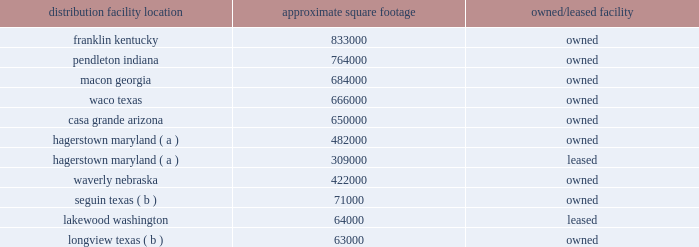The following is a list of distribution locations including the approximate square footage and if the location is leased or owned: .
Longview , texas ( b ) 63000 owned ( a ) the leased facility in hagerstown is treated as an extension of the existing owned hagerstown location and is not considered a separate distribution center .
( b ) this is a mixing center designed to process certain high-volume bulk products .
The company 2019s store support center occupies approximately 260000 square feet of owned building space in brentwood , tennessee , and the company 2019s merchandising innovation center occupies approximately 32000 square feet of leased building space in nashville , tennessee .
The company also leases approximately 8000 square feet of building space for the petsense corporate headquarters located in scottsdale , arizona .
In fiscal 2017 , we began construction on a new northeast distribution center in frankfort , new york , as well as an expansion of our existing distribution center in waverly , nebraska , which will provide additional distribution capacity once construction is completed .
Item 3 .
Legal proceedings item 103 of sec regulation s-k requires disclosure of certain environmental legal proceedings if the proceeding reasonably involves potential monetary sanctions of $ 100000 or more .
We periodically receive information requests and notices of potential noncompliance with environmental laws and regulations from governmental agencies , which are addressed on a case-by-case basis with the relevant agency .
The company received a subpoena from the district attorney of yolo county , california , requesting records and information regarding its hazardous waste management and disposal practices in california .
The company and the office of the district attorney of yolo county engaged in settlement discussions which resulted in the settlement of the matter .
A consent decree reflecting the terms of settlement was filed with the yolo county superior court on june 23 , 2017 .
Under the settlement , the company agreed to a compliance plan and also agreed to pay a civil penalty and fund supplemental environmental projects furthering consumer protection and environmental enforcement in california .
The civil penalty did not differ materially from the amount accrued .
The cost of the settlement and the compliance with the consent decree will not have a material effect on our consolidated financial position , results of operations or cash flows .
The company is also involved in various litigation matters arising in the ordinary course of business .
The company believes that any estimated loss related to such matters has been adequately provided for in accrued liabilities to the extent probable and reasonably estimable .
Accordingly , the company currently expects these matters will be resolved without material adverse effect on its consolidated financial position , results of operations or cash flows .
Item 4 .
Mine safety disclosures not applicable. .
What is the total square footage of properties charged to sg&a and not cost of sales? 
Rationale: support centers and headquarters = sg&a
Computations: ((8000 + 260000) + 32000)
Answer: 300000.0. 